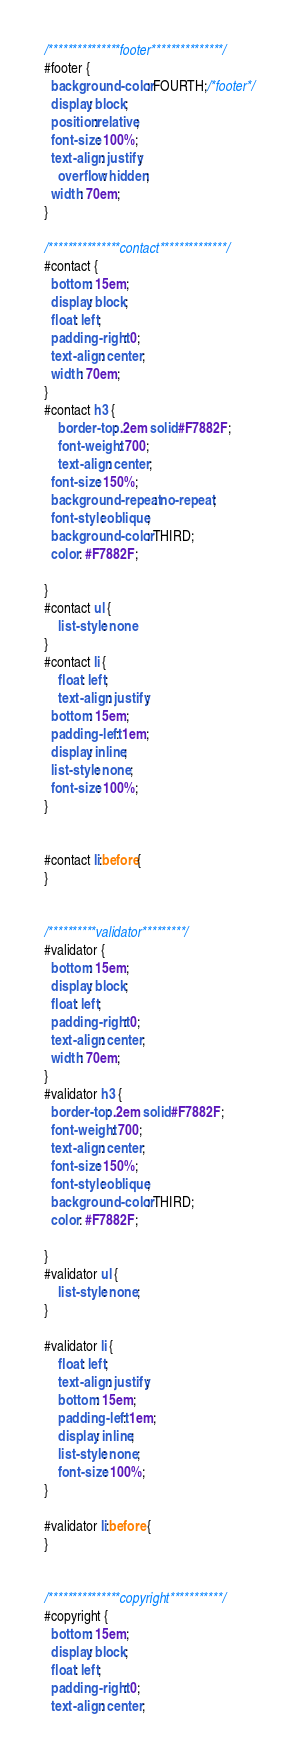<code> <loc_0><loc_0><loc_500><loc_500><_CSS_>/***************footer***************/
#footer {
  background-color: FOURTH;/*footer*/
  display: block;
  position:relative;
  font-size: 100%;
  text-align: justify;
	overflow: hidden;
  width: 70em;
}

/***************contact**************/
#contact {
  bottom: 15em;
  display: block;
  float: left;
  padding-right: 0;
  text-align: center;
  width: 70em;
}
#contact h3 {
	border-top: .2em solid #F7882F;
	font-weight: 700;
	text-align: center;
  font-size: 150%;
  background-repeat: no-repeat;
  font-style: oblique;
  background-color: THIRD;
  color: #F7882F;

}
#contact ul {
	list-style: none
}
#contact li {
	float: left;
	text-align: justify;
  bottom: 15em;
  padding-left: 1em;
  display: inline;
  list-style: none;
  font-size: 100%;
}


#contact li:before{
}


/**********validator*********/
#validator {
  bottom: 15em;
  display: block;
  float: left;
  padding-right: 0;
  text-align: center;
  width: 70em;
}
#validator h3 {
  border-top: .2em solid #F7882F;
  font-weight: 700;
  text-align: center;
  font-size: 150%;
  font-style: oblique;
  background-color: THIRD;
  color: #F7882F;

}
#validator ul {
	list-style: none;
}

#validator li {
	float: left;
	text-align: justify;
	bottom: 15em;
	padding-left: 1em;
	display: inline;
	list-style: none;
	font-size: 100%;
}

#validator li:before {
}


/***************copyright***********/
#copyright {
  bottom: 15em;
  display: block;
  float: left;
  padding-right: 0;
  text-align: center;</code> 